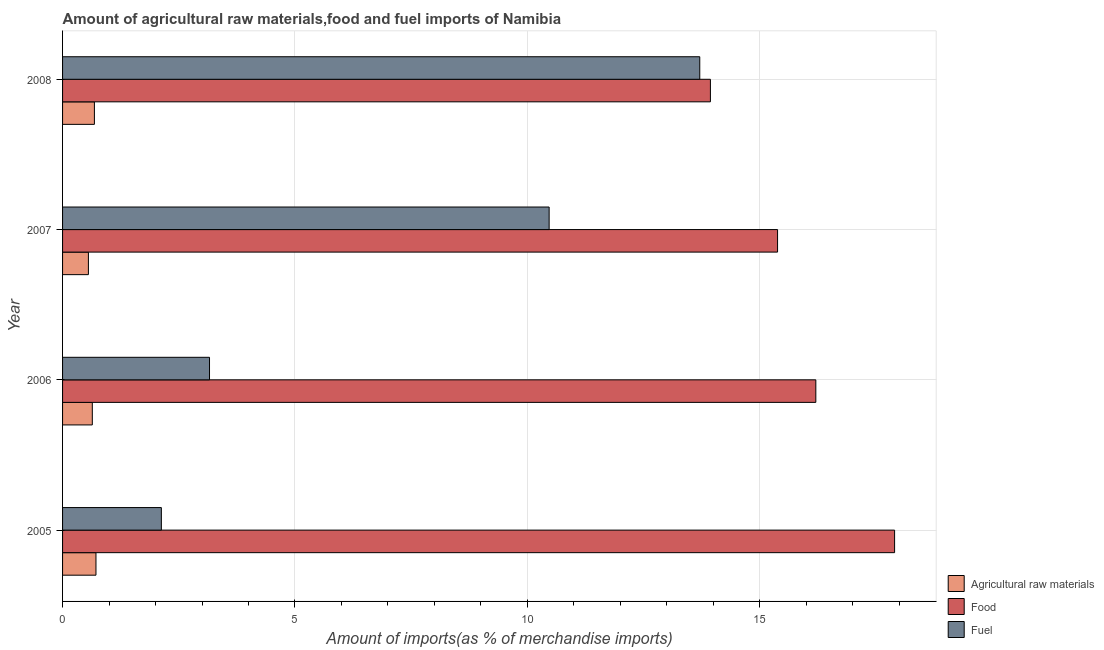Are the number of bars per tick equal to the number of legend labels?
Offer a terse response. Yes. What is the label of the 2nd group of bars from the top?
Keep it short and to the point. 2007. In how many cases, is the number of bars for a given year not equal to the number of legend labels?
Make the answer very short. 0. What is the percentage of raw materials imports in 2005?
Your answer should be compact. 0.72. Across all years, what is the maximum percentage of raw materials imports?
Offer a terse response. 0.72. Across all years, what is the minimum percentage of food imports?
Your answer should be compact. 13.94. What is the total percentage of raw materials imports in the graph?
Offer a very short reply. 2.6. What is the difference between the percentage of raw materials imports in 2005 and that in 2008?
Offer a very short reply. 0.03. What is the difference between the percentage of fuel imports in 2008 and the percentage of raw materials imports in 2005?
Offer a terse response. 12.99. What is the average percentage of food imports per year?
Keep it short and to the point. 15.86. In the year 2005, what is the difference between the percentage of fuel imports and percentage of food imports?
Provide a short and direct response. -15.78. What is the ratio of the percentage of fuel imports in 2005 to that in 2007?
Provide a short and direct response. 0.2. Is the percentage of food imports in 2006 less than that in 2007?
Provide a short and direct response. No. Is the difference between the percentage of food imports in 2007 and 2008 greater than the difference between the percentage of fuel imports in 2007 and 2008?
Your response must be concise. Yes. What is the difference between the highest and the second highest percentage of raw materials imports?
Provide a short and direct response. 0.03. What is the difference between the highest and the lowest percentage of raw materials imports?
Your response must be concise. 0.16. In how many years, is the percentage of food imports greater than the average percentage of food imports taken over all years?
Provide a short and direct response. 2. Is the sum of the percentage of food imports in 2005 and 2007 greater than the maximum percentage of raw materials imports across all years?
Keep it short and to the point. Yes. What does the 2nd bar from the top in 2006 represents?
Offer a terse response. Food. What does the 1st bar from the bottom in 2007 represents?
Offer a very short reply. Agricultural raw materials. How many years are there in the graph?
Provide a succinct answer. 4. Are the values on the major ticks of X-axis written in scientific E-notation?
Your answer should be very brief. No. Does the graph contain any zero values?
Make the answer very short. No. Does the graph contain grids?
Your answer should be compact. Yes. How many legend labels are there?
Offer a terse response. 3. What is the title of the graph?
Your answer should be very brief. Amount of agricultural raw materials,food and fuel imports of Namibia. Does "Domestic" appear as one of the legend labels in the graph?
Make the answer very short. No. What is the label or title of the X-axis?
Offer a very short reply. Amount of imports(as % of merchandise imports). What is the label or title of the Y-axis?
Your answer should be very brief. Year. What is the Amount of imports(as % of merchandise imports) in Agricultural raw materials in 2005?
Provide a short and direct response. 0.72. What is the Amount of imports(as % of merchandise imports) of Food in 2005?
Give a very brief answer. 17.9. What is the Amount of imports(as % of merchandise imports) of Fuel in 2005?
Offer a terse response. 2.13. What is the Amount of imports(as % of merchandise imports) of Agricultural raw materials in 2006?
Offer a terse response. 0.64. What is the Amount of imports(as % of merchandise imports) in Food in 2006?
Your answer should be compact. 16.21. What is the Amount of imports(as % of merchandise imports) of Fuel in 2006?
Your response must be concise. 3.16. What is the Amount of imports(as % of merchandise imports) of Agricultural raw materials in 2007?
Make the answer very short. 0.56. What is the Amount of imports(as % of merchandise imports) in Food in 2007?
Give a very brief answer. 15.38. What is the Amount of imports(as % of merchandise imports) of Fuel in 2007?
Ensure brevity in your answer.  10.47. What is the Amount of imports(as % of merchandise imports) of Agricultural raw materials in 2008?
Keep it short and to the point. 0.69. What is the Amount of imports(as % of merchandise imports) in Food in 2008?
Offer a very short reply. 13.94. What is the Amount of imports(as % of merchandise imports) of Fuel in 2008?
Provide a short and direct response. 13.71. Across all years, what is the maximum Amount of imports(as % of merchandise imports) in Agricultural raw materials?
Make the answer very short. 0.72. Across all years, what is the maximum Amount of imports(as % of merchandise imports) in Food?
Give a very brief answer. 17.9. Across all years, what is the maximum Amount of imports(as % of merchandise imports) in Fuel?
Your response must be concise. 13.71. Across all years, what is the minimum Amount of imports(as % of merchandise imports) in Agricultural raw materials?
Provide a succinct answer. 0.56. Across all years, what is the minimum Amount of imports(as % of merchandise imports) of Food?
Ensure brevity in your answer.  13.94. Across all years, what is the minimum Amount of imports(as % of merchandise imports) in Fuel?
Offer a very short reply. 2.13. What is the total Amount of imports(as % of merchandise imports) in Agricultural raw materials in the graph?
Offer a terse response. 2.6. What is the total Amount of imports(as % of merchandise imports) in Food in the graph?
Provide a succinct answer. 63.43. What is the total Amount of imports(as % of merchandise imports) of Fuel in the graph?
Make the answer very short. 29.47. What is the difference between the Amount of imports(as % of merchandise imports) of Agricultural raw materials in 2005 and that in 2006?
Offer a very short reply. 0.08. What is the difference between the Amount of imports(as % of merchandise imports) of Food in 2005 and that in 2006?
Give a very brief answer. 1.69. What is the difference between the Amount of imports(as % of merchandise imports) of Fuel in 2005 and that in 2006?
Offer a very short reply. -1.04. What is the difference between the Amount of imports(as % of merchandise imports) in Agricultural raw materials in 2005 and that in 2007?
Your answer should be very brief. 0.16. What is the difference between the Amount of imports(as % of merchandise imports) in Food in 2005 and that in 2007?
Provide a short and direct response. 2.52. What is the difference between the Amount of imports(as % of merchandise imports) in Fuel in 2005 and that in 2007?
Your answer should be compact. -8.34. What is the difference between the Amount of imports(as % of merchandise imports) of Agricultural raw materials in 2005 and that in 2008?
Offer a very short reply. 0.03. What is the difference between the Amount of imports(as % of merchandise imports) of Food in 2005 and that in 2008?
Keep it short and to the point. 3.96. What is the difference between the Amount of imports(as % of merchandise imports) of Fuel in 2005 and that in 2008?
Offer a terse response. -11.58. What is the difference between the Amount of imports(as % of merchandise imports) of Agricultural raw materials in 2006 and that in 2007?
Your answer should be compact. 0.08. What is the difference between the Amount of imports(as % of merchandise imports) of Food in 2006 and that in 2007?
Provide a short and direct response. 0.82. What is the difference between the Amount of imports(as % of merchandise imports) in Fuel in 2006 and that in 2007?
Your response must be concise. -7.31. What is the difference between the Amount of imports(as % of merchandise imports) of Agricultural raw materials in 2006 and that in 2008?
Your answer should be compact. -0.05. What is the difference between the Amount of imports(as % of merchandise imports) of Food in 2006 and that in 2008?
Ensure brevity in your answer.  2.27. What is the difference between the Amount of imports(as % of merchandise imports) of Fuel in 2006 and that in 2008?
Your response must be concise. -10.55. What is the difference between the Amount of imports(as % of merchandise imports) in Agricultural raw materials in 2007 and that in 2008?
Make the answer very short. -0.13. What is the difference between the Amount of imports(as % of merchandise imports) of Food in 2007 and that in 2008?
Ensure brevity in your answer.  1.44. What is the difference between the Amount of imports(as % of merchandise imports) in Fuel in 2007 and that in 2008?
Provide a short and direct response. -3.24. What is the difference between the Amount of imports(as % of merchandise imports) of Agricultural raw materials in 2005 and the Amount of imports(as % of merchandise imports) of Food in 2006?
Offer a terse response. -15.49. What is the difference between the Amount of imports(as % of merchandise imports) in Agricultural raw materials in 2005 and the Amount of imports(as % of merchandise imports) in Fuel in 2006?
Provide a succinct answer. -2.44. What is the difference between the Amount of imports(as % of merchandise imports) of Food in 2005 and the Amount of imports(as % of merchandise imports) of Fuel in 2006?
Provide a succinct answer. 14.74. What is the difference between the Amount of imports(as % of merchandise imports) in Agricultural raw materials in 2005 and the Amount of imports(as % of merchandise imports) in Food in 2007?
Ensure brevity in your answer.  -14.66. What is the difference between the Amount of imports(as % of merchandise imports) of Agricultural raw materials in 2005 and the Amount of imports(as % of merchandise imports) of Fuel in 2007?
Make the answer very short. -9.75. What is the difference between the Amount of imports(as % of merchandise imports) in Food in 2005 and the Amount of imports(as % of merchandise imports) in Fuel in 2007?
Offer a very short reply. 7.43. What is the difference between the Amount of imports(as % of merchandise imports) of Agricultural raw materials in 2005 and the Amount of imports(as % of merchandise imports) of Food in 2008?
Provide a short and direct response. -13.22. What is the difference between the Amount of imports(as % of merchandise imports) of Agricultural raw materials in 2005 and the Amount of imports(as % of merchandise imports) of Fuel in 2008?
Give a very brief answer. -12.99. What is the difference between the Amount of imports(as % of merchandise imports) in Food in 2005 and the Amount of imports(as % of merchandise imports) in Fuel in 2008?
Your answer should be very brief. 4.19. What is the difference between the Amount of imports(as % of merchandise imports) of Agricultural raw materials in 2006 and the Amount of imports(as % of merchandise imports) of Food in 2007?
Make the answer very short. -14.74. What is the difference between the Amount of imports(as % of merchandise imports) in Agricultural raw materials in 2006 and the Amount of imports(as % of merchandise imports) in Fuel in 2007?
Your answer should be very brief. -9.83. What is the difference between the Amount of imports(as % of merchandise imports) in Food in 2006 and the Amount of imports(as % of merchandise imports) in Fuel in 2007?
Make the answer very short. 5.74. What is the difference between the Amount of imports(as % of merchandise imports) of Agricultural raw materials in 2006 and the Amount of imports(as % of merchandise imports) of Food in 2008?
Make the answer very short. -13.3. What is the difference between the Amount of imports(as % of merchandise imports) of Agricultural raw materials in 2006 and the Amount of imports(as % of merchandise imports) of Fuel in 2008?
Your answer should be compact. -13.07. What is the difference between the Amount of imports(as % of merchandise imports) of Food in 2006 and the Amount of imports(as % of merchandise imports) of Fuel in 2008?
Your response must be concise. 2.5. What is the difference between the Amount of imports(as % of merchandise imports) in Agricultural raw materials in 2007 and the Amount of imports(as % of merchandise imports) in Food in 2008?
Make the answer very short. -13.38. What is the difference between the Amount of imports(as % of merchandise imports) of Agricultural raw materials in 2007 and the Amount of imports(as % of merchandise imports) of Fuel in 2008?
Make the answer very short. -13.15. What is the difference between the Amount of imports(as % of merchandise imports) in Food in 2007 and the Amount of imports(as % of merchandise imports) in Fuel in 2008?
Provide a short and direct response. 1.67. What is the average Amount of imports(as % of merchandise imports) in Agricultural raw materials per year?
Keep it short and to the point. 0.65. What is the average Amount of imports(as % of merchandise imports) in Food per year?
Keep it short and to the point. 15.86. What is the average Amount of imports(as % of merchandise imports) of Fuel per year?
Offer a terse response. 7.37. In the year 2005, what is the difference between the Amount of imports(as % of merchandise imports) of Agricultural raw materials and Amount of imports(as % of merchandise imports) of Food?
Provide a short and direct response. -17.18. In the year 2005, what is the difference between the Amount of imports(as % of merchandise imports) of Agricultural raw materials and Amount of imports(as % of merchandise imports) of Fuel?
Give a very brief answer. -1.41. In the year 2005, what is the difference between the Amount of imports(as % of merchandise imports) of Food and Amount of imports(as % of merchandise imports) of Fuel?
Provide a short and direct response. 15.78. In the year 2006, what is the difference between the Amount of imports(as % of merchandise imports) in Agricultural raw materials and Amount of imports(as % of merchandise imports) in Food?
Offer a very short reply. -15.57. In the year 2006, what is the difference between the Amount of imports(as % of merchandise imports) of Agricultural raw materials and Amount of imports(as % of merchandise imports) of Fuel?
Your answer should be compact. -2.52. In the year 2006, what is the difference between the Amount of imports(as % of merchandise imports) in Food and Amount of imports(as % of merchandise imports) in Fuel?
Your response must be concise. 13.05. In the year 2007, what is the difference between the Amount of imports(as % of merchandise imports) in Agricultural raw materials and Amount of imports(as % of merchandise imports) in Food?
Give a very brief answer. -14.83. In the year 2007, what is the difference between the Amount of imports(as % of merchandise imports) in Agricultural raw materials and Amount of imports(as % of merchandise imports) in Fuel?
Offer a very short reply. -9.91. In the year 2007, what is the difference between the Amount of imports(as % of merchandise imports) in Food and Amount of imports(as % of merchandise imports) in Fuel?
Give a very brief answer. 4.91. In the year 2008, what is the difference between the Amount of imports(as % of merchandise imports) in Agricultural raw materials and Amount of imports(as % of merchandise imports) in Food?
Provide a succinct answer. -13.25. In the year 2008, what is the difference between the Amount of imports(as % of merchandise imports) of Agricultural raw materials and Amount of imports(as % of merchandise imports) of Fuel?
Your answer should be compact. -13.02. In the year 2008, what is the difference between the Amount of imports(as % of merchandise imports) in Food and Amount of imports(as % of merchandise imports) in Fuel?
Ensure brevity in your answer.  0.23. What is the ratio of the Amount of imports(as % of merchandise imports) of Agricultural raw materials in 2005 to that in 2006?
Give a very brief answer. 1.12. What is the ratio of the Amount of imports(as % of merchandise imports) of Food in 2005 to that in 2006?
Provide a short and direct response. 1.1. What is the ratio of the Amount of imports(as % of merchandise imports) of Fuel in 2005 to that in 2006?
Your answer should be very brief. 0.67. What is the ratio of the Amount of imports(as % of merchandise imports) of Agricultural raw materials in 2005 to that in 2007?
Your answer should be compact. 1.29. What is the ratio of the Amount of imports(as % of merchandise imports) in Food in 2005 to that in 2007?
Give a very brief answer. 1.16. What is the ratio of the Amount of imports(as % of merchandise imports) of Fuel in 2005 to that in 2007?
Make the answer very short. 0.2. What is the ratio of the Amount of imports(as % of merchandise imports) of Agricultural raw materials in 2005 to that in 2008?
Offer a very short reply. 1.05. What is the ratio of the Amount of imports(as % of merchandise imports) in Food in 2005 to that in 2008?
Ensure brevity in your answer.  1.28. What is the ratio of the Amount of imports(as % of merchandise imports) in Fuel in 2005 to that in 2008?
Provide a succinct answer. 0.15. What is the ratio of the Amount of imports(as % of merchandise imports) of Agricultural raw materials in 2006 to that in 2007?
Offer a terse response. 1.15. What is the ratio of the Amount of imports(as % of merchandise imports) in Food in 2006 to that in 2007?
Provide a succinct answer. 1.05. What is the ratio of the Amount of imports(as % of merchandise imports) of Fuel in 2006 to that in 2007?
Offer a very short reply. 0.3. What is the ratio of the Amount of imports(as % of merchandise imports) in Agricultural raw materials in 2006 to that in 2008?
Make the answer very short. 0.93. What is the ratio of the Amount of imports(as % of merchandise imports) in Food in 2006 to that in 2008?
Make the answer very short. 1.16. What is the ratio of the Amount of imports(as % of merchandise imports) in Fuel in 2006 to that in 2008?
Provide a succinct answer. 0.23. What is the ratio of the Amount of imports(as % of merchandise imports) of Agricultural raw materials in 2007 to that in 2008?
Offer a very short reply. 0.81. What is the ratio of the Amount of imports(as % of merchandise imports) in Food in 2007 to that in 2008?
Your response must be concise. 1.1. What is the ratio of the Amount of imports(as % of merchandise imports) in Fuel in 2007 to that in 2008?
Give a very brief answer. 0.76. What is the difference between the highest and the second highest Amount of imports(as % of merchandise imports) in Agricultural raw materials?
Your response must be concise. 0.03. What is the difference between the highest and the second highest Amount of imports(as % of merchandise imports) of Food?
Keep it short and to the point. 1.69. What is the difference between the highest and the second highest Amount of imports(as % of merchandise imports) of Fuel?
Provide a short and direct response. 3.24. What is the difference between the highest and the lowest Amount of imports(as % of merchandise imports) of Agricultural raw materials?
Your response must be concise. 0.16. What is the difference between the highest and the lowest Amount of imports(as % of merchandise imports) of Food?
Your answer should be very brief. 3.96. What is the difference between the highest and the lowest Amount of imports(as % of merchandise imports) in Fuel?
Keep it short and to the point. 11.58. 